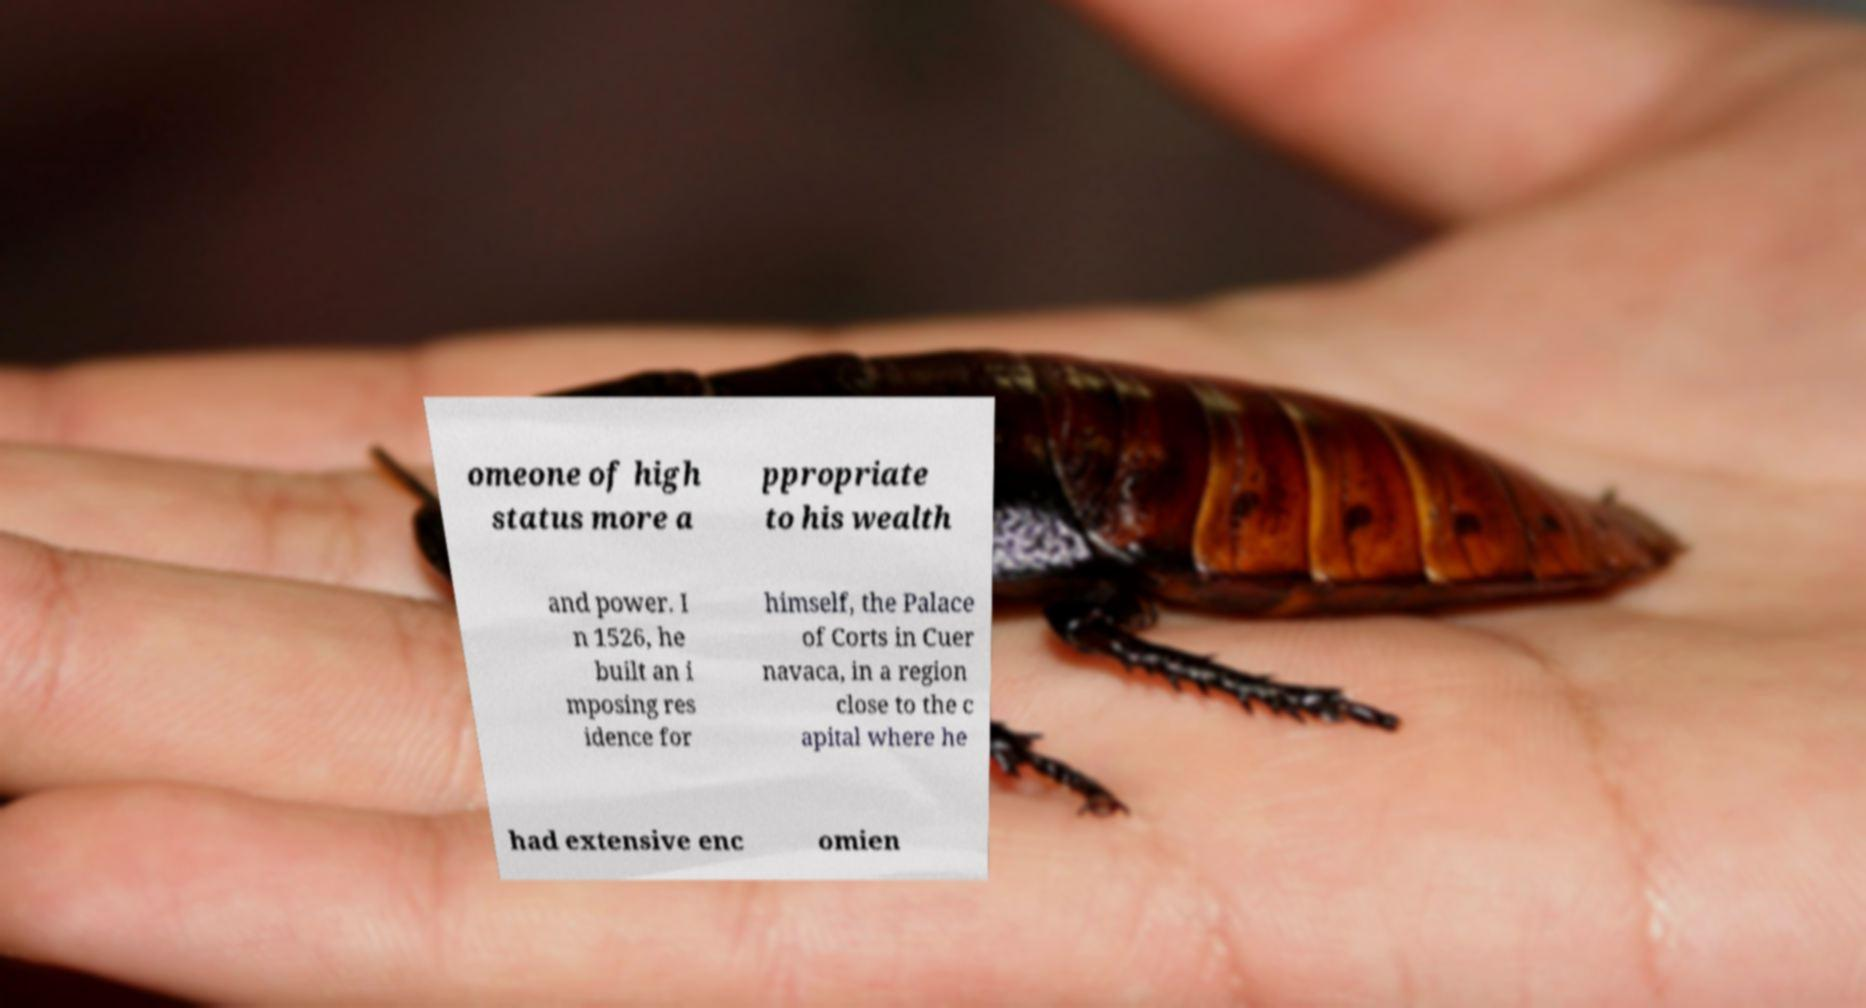Can you read and provide the text displayed in the image?This photo seems to have some interesting text. Can you extract and type it out for me? omeone of high status more a ppropriate to his wealth and power. I n 1526, he built an i mposing res idence for himself, the Palace of Corts in Cuer navaca, in a region close to the c apital where he had extensive enc omien 